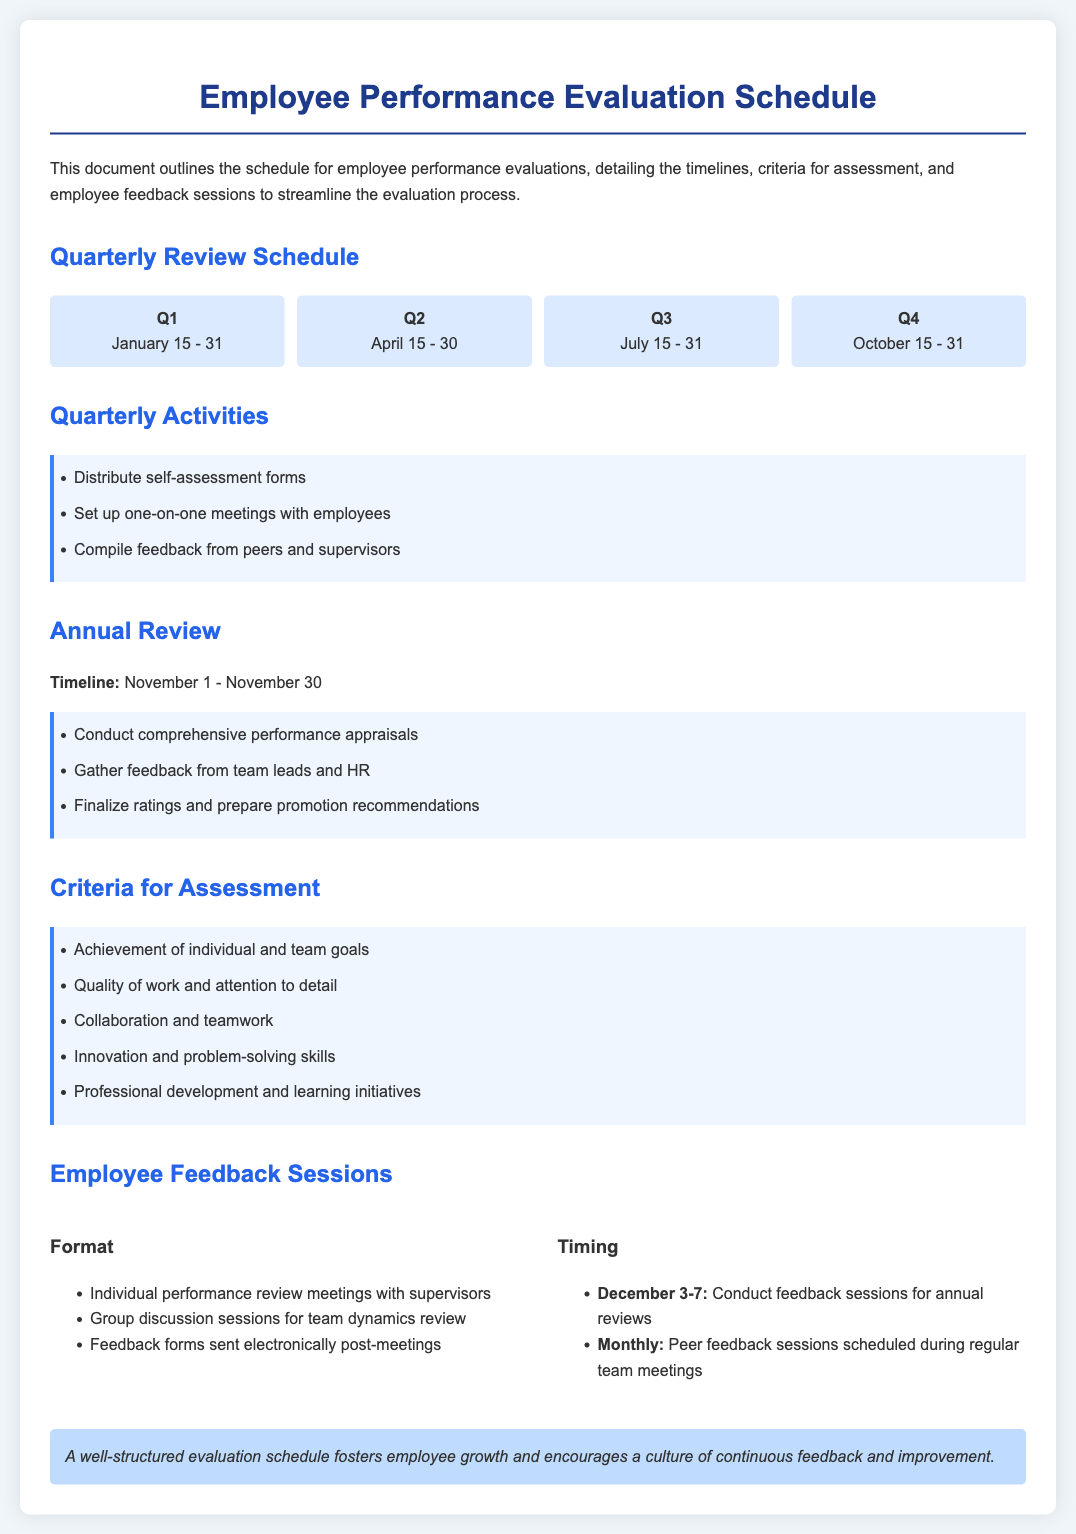What are the dates for Q1 reviews? The dates for Q1 reviews are provided in the timeline section for Q1, which is from January 15 to January 31.
Answer: January 15 - 31 What is the timeline for the Annual Review? The timeline for the Annual Review is stated in the document, which provides specific dates for it.
Answer: November 1 - November 30 How many criteria are listed for assessment? The document lists several criteria for assessment under the specific section, allowing us to count them.
Answer: Five When are the feedback sessions for annual reviews scheduled? The timing for the feedback sessions is mentioned clearly to determine the exact days.
Answer: December 3-7 What activity occurs in Q4 of the quarterly review schedule? The activities for Q4 are the same as for other quarters, but we can identify it from the list of quarterly activities.
Answer: Compile feedback from peers and supervisors How many quarters are mentioned in the document? The document outlines the quarterly review schedule divided into four sections representing each quarter.
Answer: Four What is one criterion for assessment? There are multiple criteria listed, and we can select one as an example from that list.
Answer: Achievement of individual and team goals What is the format for feedback sessions? The document specifies the format under which feedback sessions are conducted, allowing us to pick a detail.
Answer: Individual performance review meetings with supervisors 